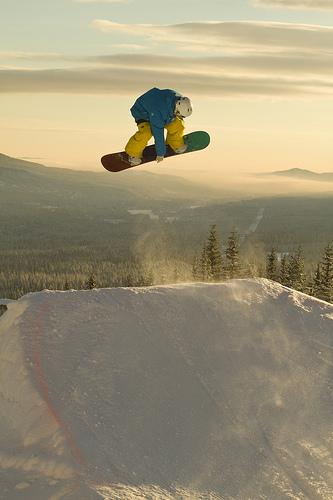Report on the scenery observed in the background of the picture. In the distance, there are mountains with forests and a wooded valley below them, with white clouds in the sky against a sunset backdrop. Describe the natural elements present in the scene. There are grey clouds in the sky, mountains in the distant, white hazy clouds between the mountains, and tall green trees behind the ramp. Mention the essential protective gear of the athlete in the image. The snowboarder is wearing a white safety helmet, which is crucial for protection during such sports activities. Give an account of the primary action taking place in the picture. A snowboarder wearing yellow pants and a blue jacket is performing a trick in mid-air above a snow ramp, holding a red and green snowboard. Summarize the most striking aspect of the snowboarding scene in the image. The snowboarder takes off from the snow ramp and demonstrates extraordinary athleticism by performing a thrilling stunt in mid-air. State what is remarkable about the ramp for snowboarding in the picture. The snow ramp, constructed out of snow, allows snowboarders to showcase impressive tricks and stunts in the air. In your own words, explain what the snowboarder is doing. The fearless snowboarder is catching air and skillfully executing an impressive trick while soaring above the snowy ramp. Provide a brief overview of the main features of the snowboard. The snowboard has a red and green design, reflecting the rider's personal style choice while performing stunts on the snow. Identify the prevalent color scheme of the image's primary focal point. The colorful snowboarder is adorned in a blue jacket and yellow pants, while holding onto a red and green snowboard. Comment on the outerwear of the individual participating in the sport in the image. The person is clad in a long-sleeved blue jacket, which looks warm and suitable for the winter weather, as well as a pair of yellow pants. 